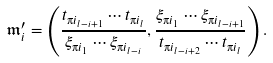Convert formula to latex. <formula><loc_0><loc_0><loc_500><loc_500>\mathfrak { m } ^ { \prime } _ { i } = \left ( \frac { t _ { \i i _ { l - i + 1 } } \cdots t _ { \i i _ { l } } } { \xi _ { \i i _ { 1 } } \cdots \xi _ { \i i _ { l - i } } } , \frac { \xi _ { \i i _ { 1 } } \cdots \xi _ { \i i _ { l - i + 1 } } } { t _ { \i i _ { l - i + 2 } } \cdots t _ { \i i _ { l } } } \right ) .</formula> 